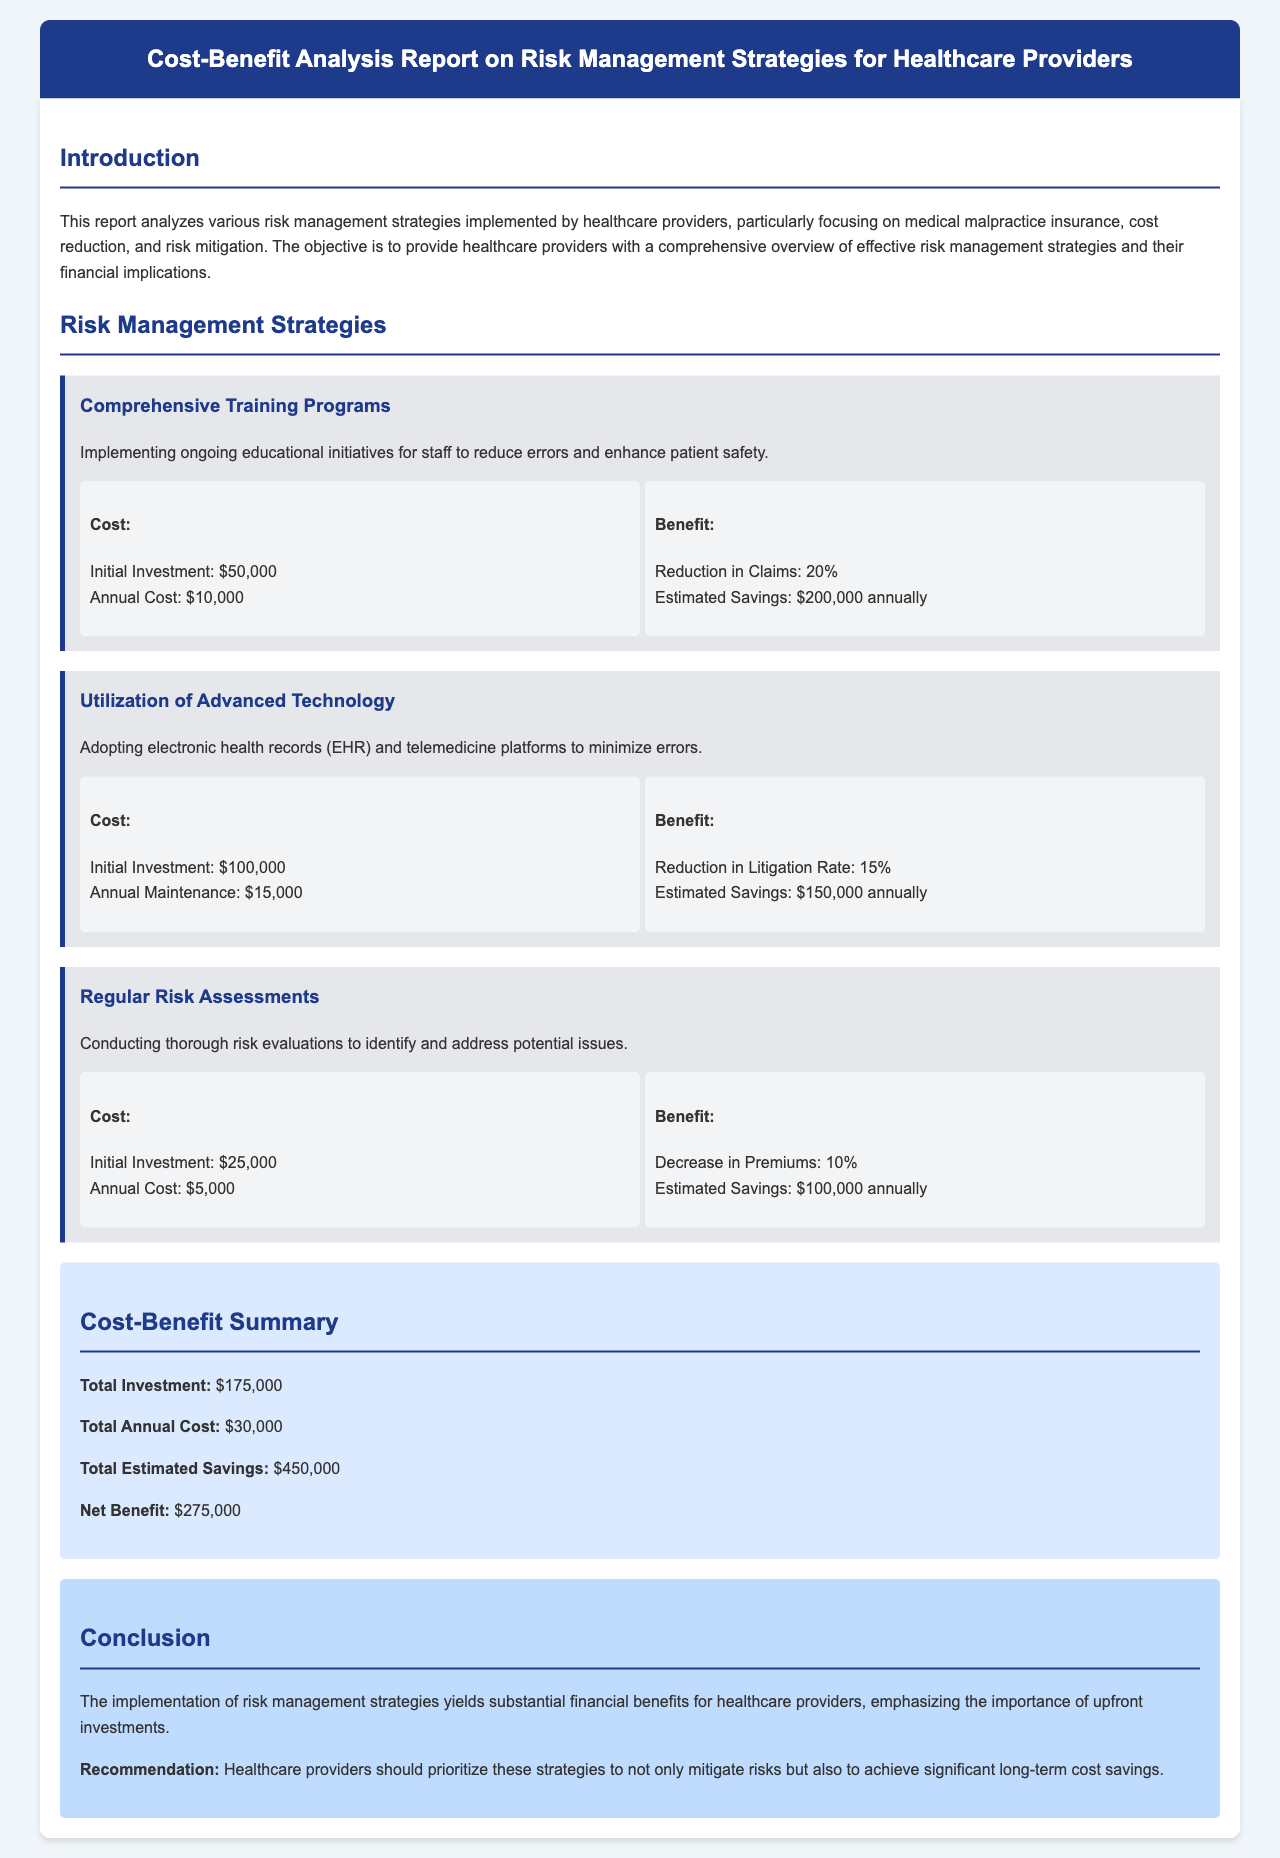what is the title of the report? The title of the report is provided at the top of the document header.
Answer: Cost-Benefit Analysis Report on Risk Management Strategies for Healthcare Providers what is the initial investment for Comprehensive Training Programs? The document specifies the cost associated with each strategy, including the initial investment for Comprehensive Training Programs.
Answer: $50,000 what percentage reduction in claims is estimated from Comprehensive Training Programs? The estimated percentage reduction in claims is directly provided in the document under the benefits for this strategy.
Answer: 20% what is the total annual cost of all strategies combined? The total annual cost is calculated and summarized in the Cost-Benefit Summary section of the document.
Answer: $30,000 what is the total estimated savings from all strategies? The total estimated savings is also summarized in the Cost-Benefit Summary section of the document.
Answer: $450,000 what is the net benefit reported in the summary? The Net Benefit is calculated based on total investment and total estimated savings as detailed in the summary.
Answer: $275,000 what recommendation is given in the conclusion? The conclusion provides a specific recommendation for healthcare providers regarding risk management strategies.
Answer: prioritize these strategies what is the annual maintenance cost for Advanced Technology? The document includes cost breakdowns for each risk management strategy, specifying the annual maintenance cost for Advanced Technology.
Answer: $15,000 what is the estimated savings from Regular Risk Assessments? The document clearly states the estimated savings attributed to Regular Risk Assessments under its benefits section.
Answer: $100,000 